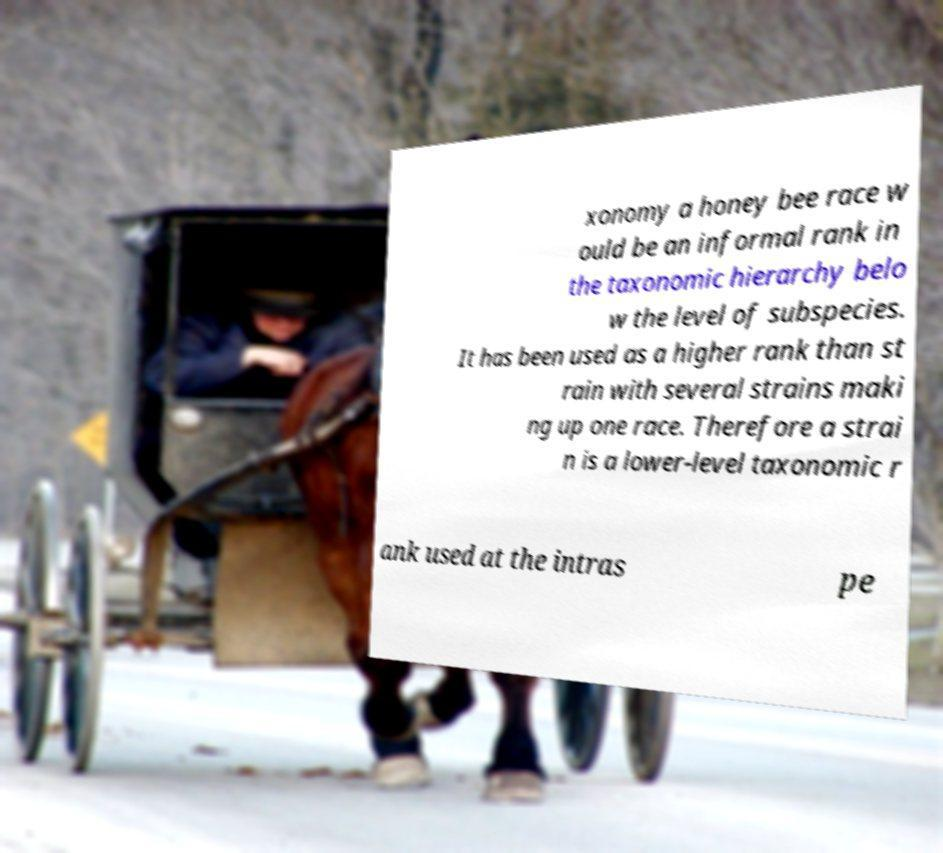Please identify and transcribe the text found in this image. xonomy a honey bee race w ould be an informal rank in the taxonomic hierarchy belo w the level of subspecies. It has been used as a higher rank than st rain with several strains maki ng up one race. Therefore a strai n is a lower-level taxonomic r ank used at the intras pe 